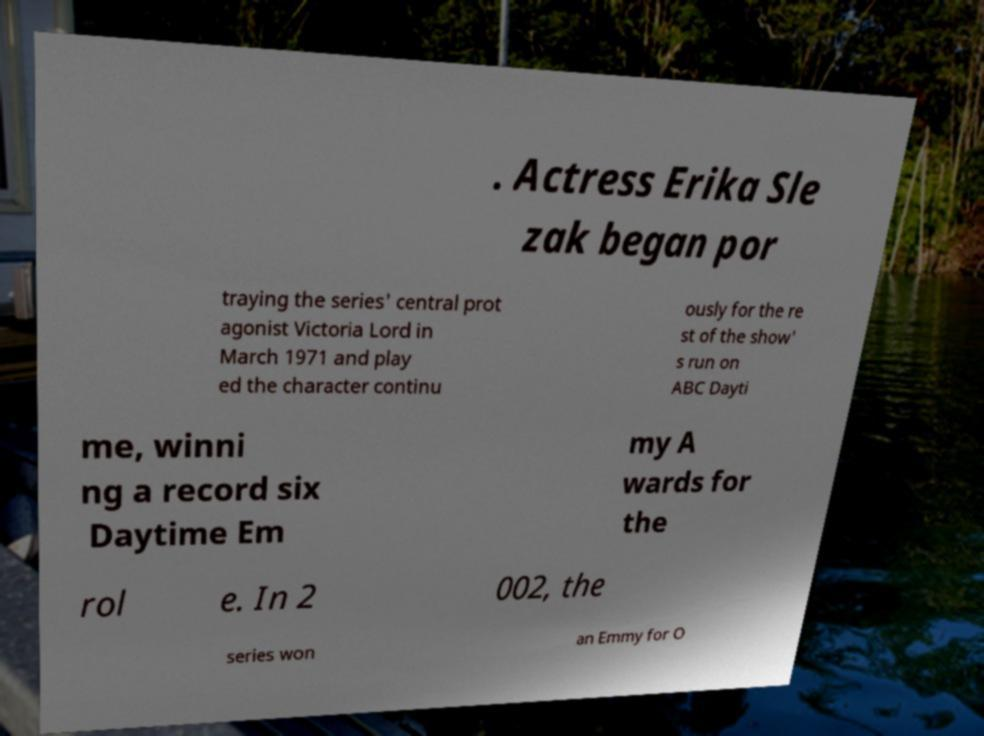Can you accurately transcribe the text from the provided image for me? . Actress Erika Sle zak began por traying the series' central prot agonist Victoria Lord in March 1971 and play ed the character continu ously for the re st of the show' s run on ABC Dayti me, winni ng a record six Daytime Em my A wards for the rol e. In 2 002, the series won an Emmy for O 